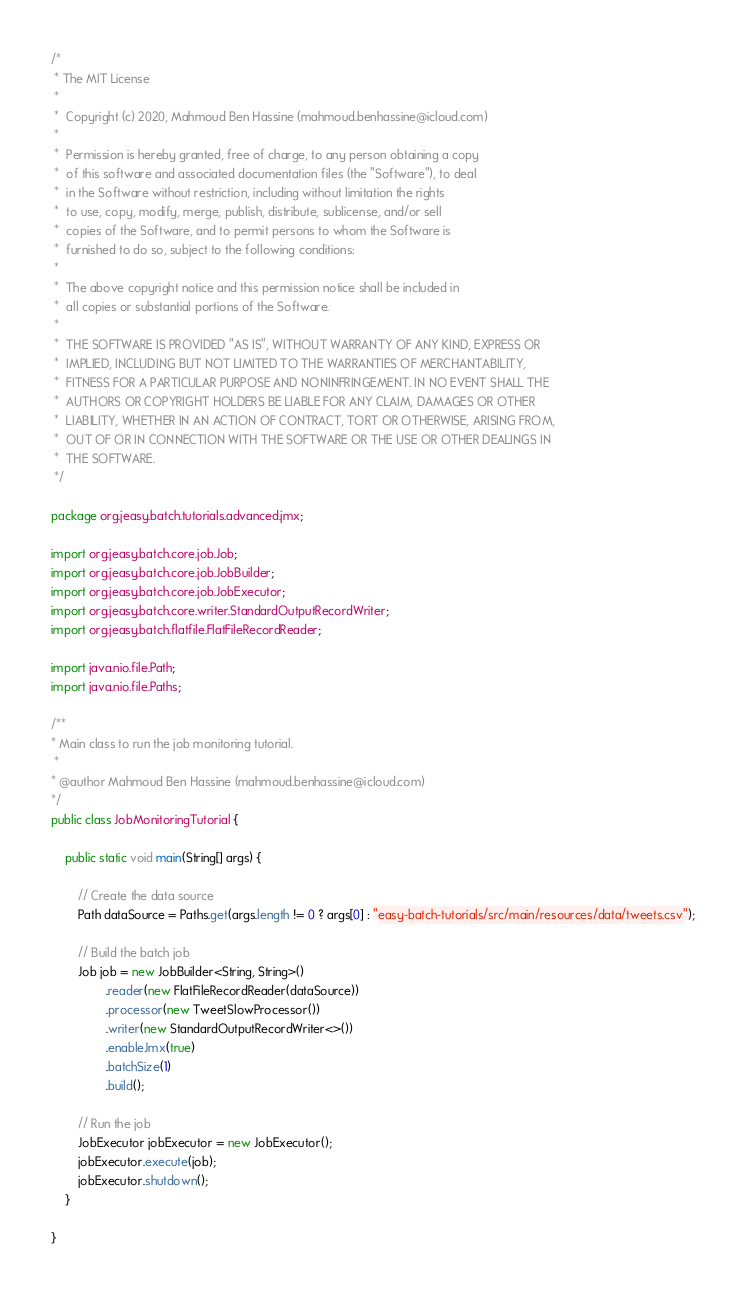<code> <loc_0><loc_0><loc_500><loc_500><_Java_>/*
 * The MIT License
 *
 *  Copyright (c) 2020, Mahmoud Ben Hassine (mahmoud.benhassine@icloud.com)
 *
 *  Permission is hereby granted, free of charge, to any person obtaining a copy
 *  of this software and associated documentation files (the "Software"), to deal
 *  in the Software without restriction, including without limitation the rights
 *  to use, copy, modify, merge, publish, distribute, sublicense, and/or sell
 *  copies of the Software, and to permit persons to whom the Software is
 *  furnished to do so, subject to the following conditions:
 *
 *  The above copyright notice and this permission notice shall be included in
 *  all copies or substantial portions of the Software.
 *
 *  THE SOFTWARE IS PROVIDED "AS IS", WITHOUT WARRANTY OF ANY KIND, EXPRESS OR
 *  IMPLIED, INCLUDING BUT NOT LIMITED TO THE WARRANTIES OF MERCHANTABILITY,
 *  FITNESS FOR A PARTICULAR PURPOSE AND NONINFRINGEMENT. IN NO EVENT SHALL THE
 *  AUTHORS OR COPYRIGHT HOLDERS BE LIABLE FOR ANY CLAIM, DAMAGES OR OTHER
 *  LIABILITY, WHETHER IN AN ACTION OF CONTRACT, TORT OR OTHERWISE, ARISING FROM,
 *  OUT OF OR IN CONNECTION WITH THE SOFTWARE OR THE USE OR OTHER DEALINGS IN
 *  THE SOFTWARE.
 */

package org.jeasy.batch.tutorials.advanced.jmx;

import org.jeasy.batch.core.job.Job;
import org.jeasy.batch.core.job.JobBuilder;
import org.jeasy.batch.core.job.JobExecutor;
import org.jeasy.batch.core.writer.StandardOutputRecordWriter;
import org.jeasy.batch.flatfile.FlatFileRecordReader;

import java.nio.file.Path;
import java.nio.file.Paths;

/**
* Main class to run the job monitoring tutorial.
 *
* @author Mahmoud Ben Hassine (mahmoud.benhassine@icloud.com)
*/
public class JobMonitoringTutorial {

    public static void main(String[] args) {

        // Create the data source
        Path dataSource = Paths.get(args.length != 0 ? args[0] : "easy-batch-tutorials/src/main/resources/data/tweets.csv");
        
        // Build the batch job
        Job job = new JobBuilder<String, String>()
                .reader(new FlatFileRecordReader(dataSource))
                .processor(new TweetSlowProcessor())
                .writer(new StandardOutputRecordWriter<>())
                .enableJmx(true)
                .batchSize(1)
                .build();

        // Run the job
        JobExecutor jobExecutor = new JobExecutor();
        jobExecutor.execute(job);
        jobExecutor.shutdown();
    }

}
</code> 